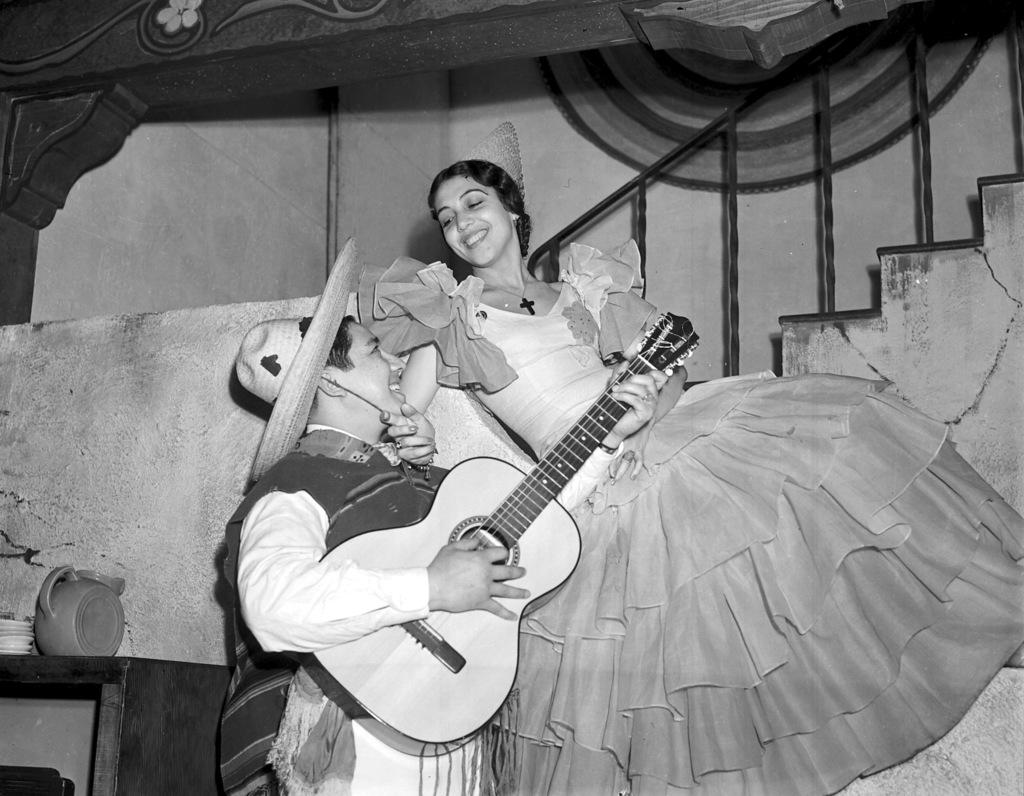Who or what can be seen in the image? There are people in the image. What are the people doing in the image? The people are standing and holding guitars in their hands. What is the color scheme of the image? The image is in black and white color. What is the business of the people in the image? There is no indication of a business in the image; it simply shows people standing and holding guitars. What is the tendency of the guitars in the image? The guitars are not shown to have any specific tendency in the image; they are simply being held by the people. 